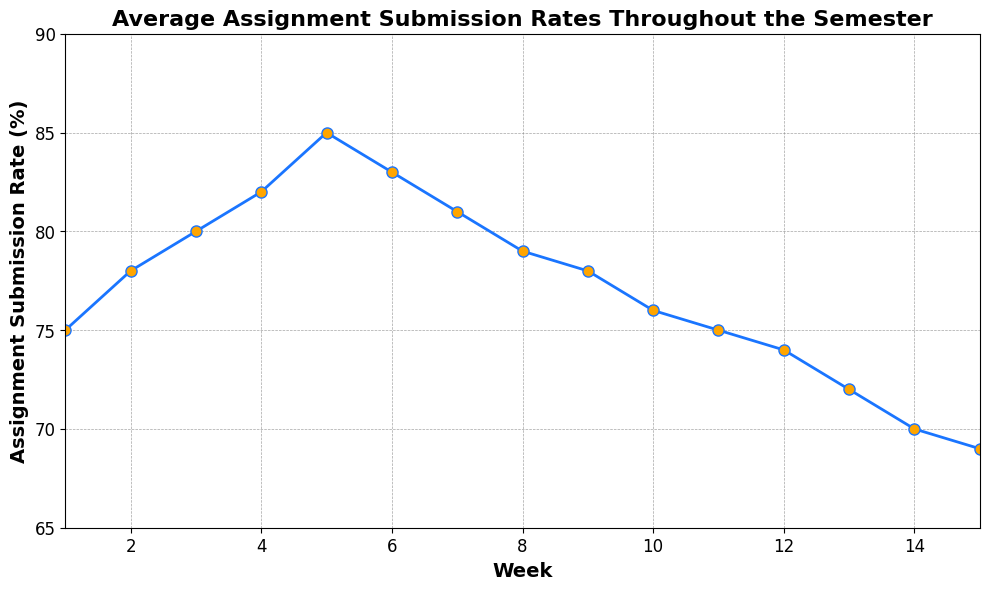What is the trend of the assignment submission rate as the semester progresses? The assignment submission rate starts at 75% in week 1, rises gradually to 85% by week 5, then declines steadily to 69% by week 15.
Answer: Decreasing What was the highest assignment submission rate and in which week did it occur? The highest assignment submission rate was 85%, which occurred in week 5.
Answer: 85%, week 5 Compare the submission rates between week 1 and week 15. What is the difference? The assignment submission rate in week 1 is 75%, and in week 15 it is 69%. The difference is calculated as 75% - 69% = 6%.
Answer: 6% How does the submission rate in week 8 compare to week 4? In week 8, the submission rate is 79%, while in week 4 it is 82%. Week 8's rate is lower than that of week 4.
Answer: Week 8 is lower What is the general trend observed in the submission rates from week 10 to week 15? From week 10 to week 15, the submission rates decline consistently from 76% to 69%.
Answer: Declining By how much did the submission rate decrease from its peak in week 5 to the end of the semester in week 15? The peak submission rate is 85% in week 5 and it drops to 69% in week 15. The decrease is 85% - 69% = 16%.
Answer: 16% In which weeks did the submission rate stay the same? The submission rate remains the same in week 1 and week 11, both at 75%.
Answer: Week 1 and week 11 What is the average assignment submission rate from week 1 to week 5? Sum the submission rates from week 1 to week 5: 75% + 78% + 80% + 82% + 85% = 400%. Divide by the number of weeks: 400% / 5 = 80%.
Answer: 80% Which week experienced the largest drop in submission rates compared to the prior week? The largest drop occurred between week 5 (85%) and week 6 (83%), which is 85% - 83% = 2%.
Answer: Week 5 to Week 6 How does the submission rate change visually from week 5 onwards? Visually, the rate declines steadily as the points on the line chart descend from week 5 towards week 15.
Answer: Steady decline 